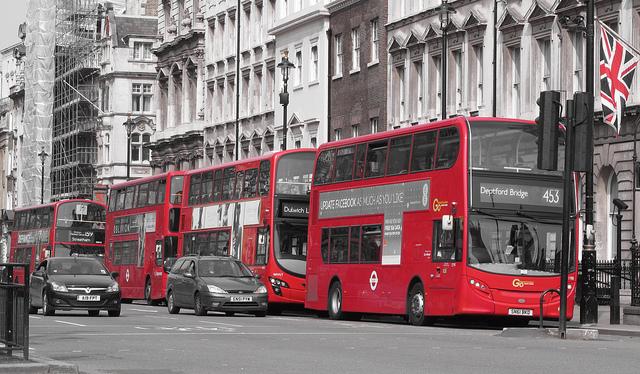What color are the buses?
Write a very short answer. Red. How many buses?
Answer briefly. 4. What nation is this photo set in?
Concise answer only. London. 